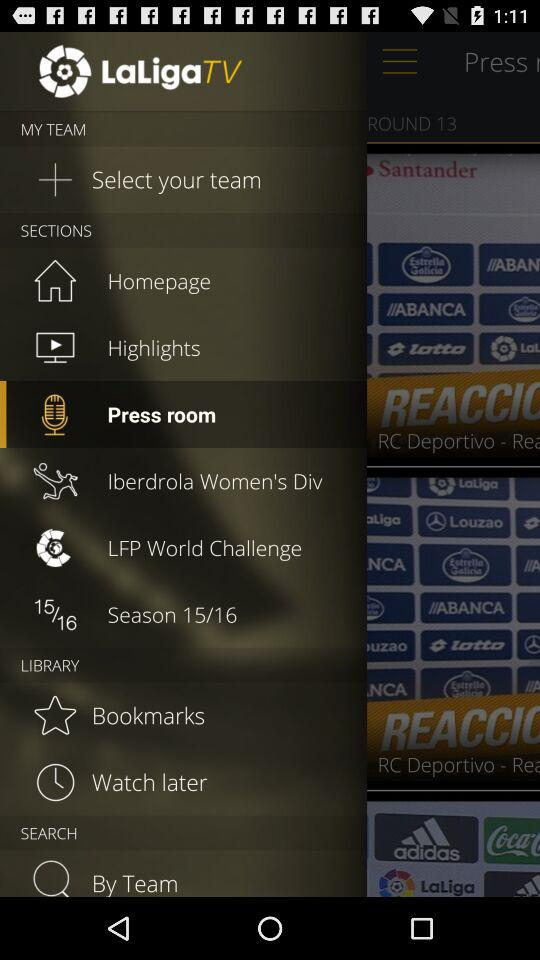What is the total number of seasons?
When the provided information is insufficient, respond with <no answer>. <no answer> 